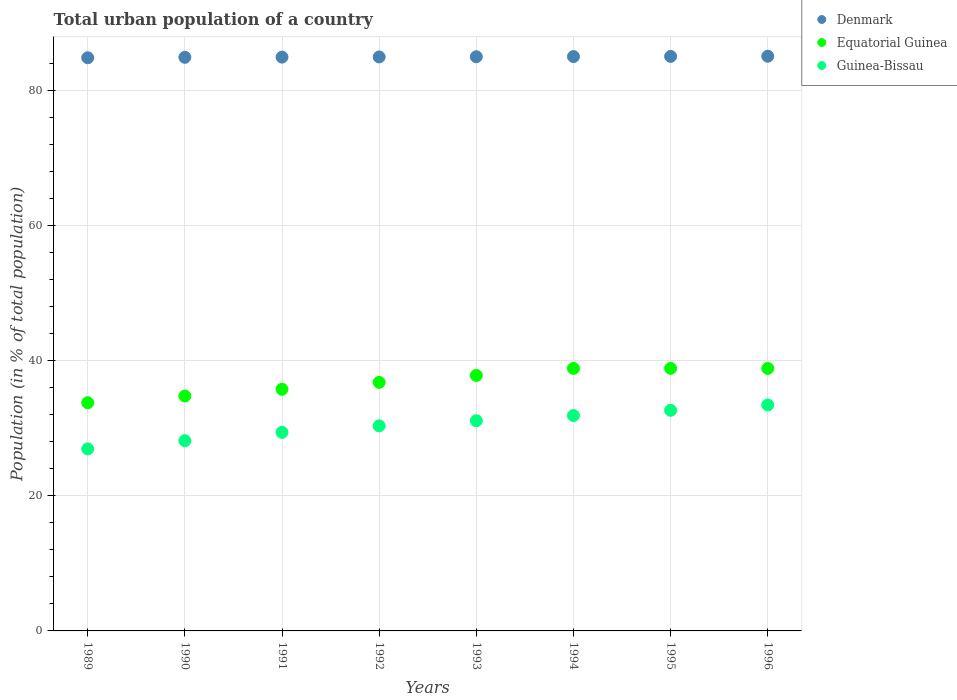What is the urban population in Guinea-Bissau in 1990?
Your answer should be compact. 28.13. Across all years, what is the maximum urban population in Equatorial Guinea?
Provide a succinct answer. 38.83. Across all years, what is the minimum urban population in Equatorial Guinea?
Your answer should be compact. 33.76. What is the total urban population in Equatorial Guinea in the graph?
Make the answer very short. 295.3. What is the difference between the urban population in Guinea-Bissau in 1991 and that in 1994?
Provide a short and direct response. -2.49. What is the difference between the urban population in Guinea-Bissau in 1994 and the urban population in Equatorial Guinea in 1995?
Your answer should be compact. -6.98. What is the average urban population in Guinea-Bissau per year?
Your response must be concise. 30.47. In the year 1993, what is the difference between the urban population in Equatorial Guinea and urban population in Denmark?
Your answer should be compact. -47.13. In how many years, is the urban population in Denmark greater than 56 %?
Provide a short and direct response. 8. What is the ratio of the urban population in Guinea-Bissau in 1992 to that in 1994?
Provide a succinct answer. 0.95. What is the difference between the highest and the second highest urban population in Guinea-Bissau?
Provide a succinct answer. 0.79. What is the difference between the highest and the lowest urban population in Denmark?
Make the answer very short. 0.23. In how many years, is the urban population in Denmark greater than the average urban population in Denmark taken over all years?
Give a very brief answer. 4. Is it the case that in every year, the sum of the urban population in Equatorial Guinea and urban population in Denmark  is greater than the urban population in Guinea-Bissau?
Your response must be concise. Yes. Does the urban population in Guinea-Bissau monotonically increase over the years?
Offer a terse response. Yes. Is the urban population in Guinea-Bissau strictly greater than the urban population in Equatorial Guinea over the years?
Your response must be concise. No. Is the urban population in Denmark strictly less than the urban population in Guinea-Bissau over the years?
Ensure brevity in your answer.  No. How many dotlines are there?
Your response must be concise. 3. How many years are there in the graph?
Provide a succinct answer. 8. What is the difference between two consecutive major ticks on the Y-axis?
Ensure brevity in your answer.  20. Are the values on the major ticks of Y-axis written in scientific E-notation?
Your answer should be compact. No. Where does the legend appear in the graph?
Make the answer very short. Top right. How many legend labels are there?
Give a very brief answer. 3. What is the title of the graph?
Provide a succinct answer. Total urban population of a country. Does "Israel" appear as one of the legend labels in the graph?
Offer a very short reply. No. What is the label or title of the X-axis?
Offer a very short reply. Years. What is the label or title of the Y-axis?
Ensure brevity in your answer.  Population (in % of total population). What is the Population (in % of total population) of Denmark in 1989?
Provide a succinct answer. 84.78. What is the Population (in % of total population) in Equatorial Guinea in 1989?
Ensure brevity in your answer.  33.76. What is the Population (in % of total population) of Guinea-Bissau in 1989?
Offer a terse response. 26.92. What is the Population (in % of total population) of Denmark in 1990?
Offer a terse response. 84.84. What is the Population (in % of total population) in Equatorial Guinea in 1990?
Make the answer very short. 34.74. What is the Population (in % of total population) in Guinea-Bissau in 1990?
Your answer should be very brief. 28.13. What is the Population (in % of total population) in Denmark in 1991?
Offer a very short reply. 84.87. What is the Population (in % of total population) of Equatorial Guinea in 1991?
Your answer should be very brief. 35.75. What is the Population (in % of total population) in Guinea-Bissau in 1991?
Your answer should be very brief. 29.37. What is the Population (in % of total population) in Denmark in 1992?
Make the answer very short. 84.9. What is the Population (in % of total population) in Equatorial Guinea in 1992?
Make the answer very short. 36.77. What is the Population (in % of total population) of Guinea-Bissau in 1992?
Keep it short and to the point. 30.34. What is the Population (in % of total population) in Denmark in 1993?
Provide a succinct answer. 84.92. What is the Population (in % of total population) of Equatorial Guinea in 1993?
Offer a terse response. 37.79. What is the Population (in % of total population) of Guinea-Bissau in 1993?
Ensure brevity in your answer.  31.09. What is the Population (in % of total population) in Denmark in 1994?
Offer a very short reply. 84.95. What is the Population (in % of total population) of Equatorial Guinea in 1994?
Your answer should be compact. 38.83. What is the Population (in % of total population) in Guinea-Bissau in 1994?
Give a very brief answer. 31.86. What is the Population (in % of total population) in Denmark in 1995?
Provide a succinct answer. 84.98. What is the Population (in % of total population) of Equatorial Guinea in 1995?
Ensure brevity in your answer.  38.83. What is the Population (in % of total population) of Guinea-Bissau in 1995?
Offer a very short reply. 32.63. What is the Population (in % of total population) in Denmark in 1996?
Your response must be concise. 85.01. What is the Population (in % of total population) in Equatorial Guinea in 1996?
Your answer should be very brief. 38.83. What is the Population (in % of total population) in Guinea-Bissau in 1996?
Your answer should be compact. 33.42. Across all years, what is the maximum Population (in % of total population) in Denmark?
Provide a short and direct response. 85.01. Across all years, what is the maximum Population (in % of total population) in Equatorial Guinea?
Give a very brief answer. 38.83. Across all years, what is the maximum Population (in % of total population) in Guinea-Bissau?
Provide a short and direct response. 33.42. Across all years, what is the minimum Population (in % of total population) in Denmark?
Make the answer very short. 84.78. Across all years, what is the minimum Population (in % of total population) of Equatorial Guinea?
Offer a very short reply. 33.76. Across all years, what is the minimum Population (in % of total population) of Guinea-Bissau?
Offer a terse response. 26.92. What is the total Population (in % of total population) in Denmark in the graph?
Offer a terse response. 679.25. What is the total Population (in % of total population) of Equatorial Guinea in the graph?
Provide a short and direct response. 295.3. What is the total Population (in % of total population) of Guinea-Bissau in the graph?
Provide a short and direct response. 243.76. What is the difference between the Population (in % of total population) of Denmark in 1989 and that in 1990?
Your answer should be compact. -0.07. What is the difference between the Population (in % of total population) of Equatorial Guinea in 1989 and that in 1990?
Offer a very short reply. -0.99. What is the difference between the Population (in % of total population) in Guinea-Bissau in 1989 and that in 1990?
Keep it short and to the point. -1.21. What is the difference between the Population (in % of total population) of Denmark in 1989 and that in 1991?
Give a very brief answer. -0.09. What is the difference between the Population (in % of total population) of Equatorial Guinea in 1989 and that in 1991?
Provide a short and direct response. -1.99. What is the difference between the Population (in % of total population) in Guinea-Bissau in 1989 and that in 1991?
Keep it short and to the point. -2.45. What is the difference between the Population (in % of total population) in Denmark in 1989 and that in 1992?
Give a very brief answer. -0.12. What is the difference between the Population (in % of total population) of Equatorial Guinea in 1989 and that in 1992?
Provide a succinct answer. -3.01. What is the difference between the Population (in % of total population) of Guinea-Bissau in 1989 and that in 1992?
Your answer should be compact. -3.41. What is the difference between the Population (in % of total population) of Denmark in 1989 and that in 1993?
Make the answer very short. -0.15. What is the difference between the Population (in % of total population) of Equatorial Guinea in 1989 and that in 1993?
Your answer should be compact. -4.04. What is the difference between the Population (in % of total population) of Guinea-Bissau in 1989 and that in 1993?
Provide a succinct answer. -4.17. What is the difference between the Population (in % of total population) in Denmark in 1989 and that in 1994?
Ensure brevity in your answer.  -0.17. What is the difference between the Population (in % of total population) in Equatorial Guinea in 1989 and that in 1994?
Your response must be concise. -5.08. What is the difference between the Population (in % of total population) in Guinea-Bissau in 1989 and that in 1994?
Your answer should be very brief. -4.93. What is the difference between the Population (in % of total population) in Denmark in 1989 and that in 1995?
Give a very brief answer. -0.2. What is the difference between the Population (in % of total population) of Equatorial Guinea in 1989 and that in 1995?
Your answer should be compact. -5.08. What is the difference between the Population (in % of total population) of Guinea-Bissau in 1989 and that in 1995?
Your answer should be very brief. -5.71. What is the difference between the Population (in % of total population) of Denmark in 1989 and that in 1996?
Provide a short and direct response. -0.23. What is the difference between the Population (in % of total population) of Equatorial Guinea in 1989 and that in 1996?
Offer a terse response. -5.07. What is the difference between the Population (in % of total population) in Guinea-Bissau in 1989 and that in 1996?
Your response must be concise. -6.5. What is the difference between the Population (in % of total population) in Denmark in 1990 and that in 1991?
Offer a very short reply. -0.03. What is the difference between the Population (in % of total population) in Equatorial Guinea in 1990 and that in 1991?
Your answer should be very brief. -1. What is the difference between the Population (in % of total population) of Guinea-Bissau in 1990 and that in 1991?
Keep it short and to the point. -1.24. What is the difference between the Population (in % of total population) in Denmark in 1990 and that in 1992?
Offer a very short reply. -0.06. What is the difference between the Population (in % of total population) of Equatorial Guinea in 1990 and that in 1992?
Offer a very short reply. -2.02. What is the difference between the Population (in % of total population) in Guinea-Bissau in 1990 and that in 1992?
Keep it short and to the point. -2.2. What is the difference between the Population (in % of total population) of Denmark in 1990 and that in 1993?
Your answer should be very brief. -0.08. What is the difference between the Population (in % of total population) of Equatorial Guinea in 1990 and that in 1993?
Provide a short and direct response. -3.05. What is the difference between the Population (in % of total population) of Guinea-Bissau in 1990 and that in 1993?
Your answer should be compact. -2.96. What is the difference between the Population (in % of total population) in Denmark in 1990 and that in 1994?
Offer a terse response. -0.11. What is the difference between the Population (in % of total population) in Equatorial Guinea in 1990 and that in 1994?
Ensure brevity in your answer.  -4.09. What is the difference between the Population (in % of total population) of Guinea-Bissau in 1990 and that in 1994?
Offer a terse response. -3.73. What is the difference between the Population (in % of total population) of Denmark in 1990 and that in 1995?
Offer a very short reply. -0.14. What is the difference between the Population (in % of total population) in Equatorial Guinea in 1990 and that in 1995?
Your answer should be very brief. -4.09. What is the difference between the Population (in % of total population) in Guinea-Bissau in 1990 and that in 1995?
Ensure brevity in your answer.  -4.5. What is the difference between the Population (in % of total population) in Denmark in 1990 and that in 1996?
Provide a short and direct response. -0.16. What is the difference between the Population (in % of total population) in Equatorial Guinea in 1990 and that in 1996?
Provide a short and direct response. -4.08. What is the difference between the Population (in % of total population) of Guinea-Bissau in 1990 and that in 1996?
Your answer should be compact. -5.29. What is the difference between the Population (in % of total population) of Denmark in 1991 and that in 1992?
Ensure brevity in your answer.  -0.03. What is the difference between the Population (in % of total population) of Equatorial Guinea in 1991 and that in 1992?
Offer a terse response. -1.02. What is the difference between the Population (in % of total population) in Guinea-Bissau in 1991 and that in 1992?
Your answer should be compact. -0.96. What is the difference between the Population (in % of total population) of Denmark in 1991 and that in 1993?
Offer a terse response. -0.05. What is the difference between the Population (in % of total population) of Equatorial Guinea in 1991 and that in 1993?
Provide a short and direct response. -2.04. What is the difference between the Population (in % of total population) in Guinea-Bissau in 1991 and that in 1993?
Your response must be concise. -1.72. What is the difference between the Population (in % of total population) of Denmark in 1991 and that in 1994?
Your answer should be compact. -0.08. What is the difference between the Population (in % of total population) in Equatorial Guinea in 1991 and that in 1994?
Your answer should be compact. -3.08. What is the difference between the Population (in % of total population) of Guinea-Bissau in 1991 and that in 1994?
Keep it short and to the point. -2.49. What is the difference between the Population (in % of total population) of Denmark in 1991 and that in 1995?
Your response must be concise. -0.11. What is the difference between the Population (in % of total population) of Equatorial Guinea in 1991 and that in 1995?
Keep it short and to the point. -3.09. What is the difference between the Population (in % of total population) of Guinea-Bissau in 1991 and that in 1995?
Offer a very short reply. -3.26. What is the difference between the Population (in % of total population) in Denmark in 1991 and that in 1996?
Make the answer very short. -0.14. What is the difference between the Population (in % of total population) in Equatorial Guinea in 1991 and that in 1996?
Your response must be concise. -3.08. What is the difference between the Population (in % of total population) in Guinea-Bissau in 1991 and that in 1996?
Make the answer very short. -4.05. What is the difference between the Population (in % of total population) in Denmark in 1992 and that in 1993?
Make the answer very short. -0.03. What is the difference between the Population (in % of total population) of Equatorial Guinea in 1992 and that in 1993?
Provide a succinct answer. -1.03. What is the difference between the Population (in % of total population) in Guinea-Bissau in 1992 and that in 1993?
Make the answer very short. -0.76. What is the difference between the Population (in % of total population) of Denmark in 1992 and that in 1994?
Your response must be concise. -0.05. What is the difference between the Population (in % of total population) in Equatorial Guinea in 1992 and that in 1994?
Keep it short and to the point. -2.06. What is the difference between the Population (in % of total population) in Guinea-Bissau in 1992 and that in 1994?
Keep it short and to the point. -1.52. What is the difference between the Population (in % of total population) of Denmark in 1992 and that in 1995?
Offer a terse response. -0.08. What is the difference between the Population (in % of total population) of Equatorial Guinea in 1992 and that in 1995?
Make the answer very short. -2.07. What is the difference between the Population (in % of total population) in Guinea-Bissau in 1992 and that in 1995?
Offer a terse response. -2.3. What is the difference between the Population (in % of total population) in Denmark in 1992 and that in 1996?
Your answer should be compact. -0.11. What is the difference between the Population (in % of total population) of Equatorial Guinea in 1992 and that in 1996?
Your response must be concise. -2.06. What is the difference between the Population (in % of total population) of Guinea-Bissau in 1992 and that in 1996?
Your response must be concise. -3.08. What is the difference between the Population (in % of total population) of Denmark in 1993 and that in 1994?
Your answer should be compact. -0.03. What is the difference between the Population (in % of total population) in Equatorial Guinea in 1993 and that in 1994?
Provide a succinct answer. -1.04. What is the difference between the Population (in % of total population) in Guinea-Bissau in 1993 and that in 1994?
Provide a short and direct response. -0.77. What is the difference between the Population (in % of total population) of Denmark in 1993 and that in 1995?
Keep it short and to the point. -0.05. What is the difference between the Population (in % of total population) of Equatorial Guinea in 1993 and that in 1995?
Give a very brief answer. -1.04. What is the difference between the Population (in % of total population) in Guinea-Bissau in 1993 and that in 1995?
Ensure brevity in your answer.  -1.54. What is the difference between the Population (in % of total population) in Denmark in 1993 and that in 1996?
Keep it short and to the point. -0.08. What is the difference between the Population (in % of total population) of Equatorial Guinea in 1993 and that in 1996?
Your answer should be very brief. -1.04. What is the difference between the Population (in % of total population) of Guinea-Bissau in 1993 and that in 1996?
Ensure brevity in your answer.  -2.33. What is the difference between the Population (in % of total population) of Denmark in 1994 and that in 1995?
Your answer should be very brief. -0.03. What is the difference between the Population (in % of total population) of Equatorial Guinea in 1994 and that in 1995?
Provide a succinct answer. -0. What is the difference between the Population (in % of total population) in Guinea-Bissau in 1994 and that in 1995?
Your answer should be very brief. -0.78. What is the difference between the Population (in % of total population) of Denmark in 1994 and that in 1996?
Your answer should be compact. -0.05. What is the difference between the Population (in % of total population) of Equatorial Guinea in 1994 and that in 1996?
Offer a very short reply. 0. What is the difference between the Population (in % of total population) in Guinea-Bissau in 1994 and that in 1996?
Ensure brevity in your answer.  -1.56. What is the difference between the Population (in % of total population) in Denmark in 1995 and that in 1996?
Provide a succinct answer. -0.03. What is the difference between the Population (in % of total population) in Equatorial Guinea in 1995 and that in 1996?
Provide a succinct answer. 0.01. What is the difference between the Population (in % of total population) of Guinea-Bissau in 1995 and that in 1996?
Keep it short and to the point. -0.79. What is the difference between the Population (in % of total population) of Denmark in 1989 and the Population (in % of total population) of Equatorial Guinea in 1990?
Ensure brevity in your answer.  50.03. What is the difference between the Population (in % of total population) in Denmark in 1989 and the Population (in % of total population) in Guinea-Bissau in 1990?
Your answer should be compact. 56.65. What is the difference between the Population (in % of total population) in Equatorial Guinea in 1989 and the Population (in % of total population) in Guinea-Bissau in 1990?
Offer a very short reply. 5.62. What is the difference between the Population (in % of total population) of Denmark in 1989 and the Population (in % of total population) of Equatorial Guinea in 1991?
Provide a succinct answer. 49.03. What is the difference between the Population (in % of total population) in Denmark in 1989 and the Population (in % of total population) in Guinea-Bissau in 1991?
Provide a succinct answer. 55.41. What is the difference between the Population (in % of total population) of Equatorial Guinea in 1989 and the Population (in % of total population) of Guinea-Bissau in 1991?
Ensure brevity in your answer.  4.38. What is the difference between the Population (in % of total population) of Denmark in 1989 and the Population (in % of total population) of Equatorial Guinea in 1992?
Your answer should be very brief. 48.01. What is the difference between the Population (in % of total population) of Denmark in 1989 and the Population (in % of total population) of Guinea-Bissau in 1992?
Provide a succinct answer. 54.44. What is the difference between the Population (in % of total population) of Equatorial Guinea in 1989 and the Population (in % of total population) of Guinea-Bissau in 1992?
Provide a succinct answer. 3.42. What is the difference between the Population (in % of total population) of Denmark in 1989 and the Population (in % of total population) of Equatorial Guinea in 1993?
Offer a very short reply. 46.98. What is the difference between the Population (in % of total population) of Denmark in 1989 and the Population (in % of total population) of Guinea-Bissau in 1993?
Make the answer very short. 53.69. What is the difference between the Population (in % of total population) of Equatorial Guinea in 1989 and the Population (in % of total population) of Guinea-Bissau in 1993?
Your answer should be compact. 2.66. What is the difference between the Population (in % of total population) in Denmark in 1989 and the Population (in % of total population) in Equatorial Guinea in 1994?
Your response must be concise. 45.95. What is the difference between the Population (in % of total population) in Denmark in 1989 and the Population (in % of total population) in Guinea-Bissau in 1994?
Your answer should be compact. 52.92. What is the difference between the Population (in % of total population) of Equatorial Guinea in 1989 and the Population (in % of total population) of Guinea-Bissau in 1994?
Give a very brief answer. 1.9. What is the difference between the Population (in % of total population) of Denmark in 1989 and the Population (in % of total population) of Equatorial Guinea in 1995?
Provide a short and direct response. 45.94. What is the difference between the Population (in % of total population) in Denmark in 1989 and the Population (in % of total population) in Guinea-Bissau in 1995?
Your response must be concise. 52.14. What is the difference between the Population (in % of total population) of Equatorial Guinea in 1989 and the Population (in % of total population) of Guinea-Bissau in 1995?
Your answer should be compact. 1.12. What is the difference between the Population (in % of total population) of Denmark in 1989 and the Population (in % of total population) of Equatorial Guinea in 1996?
Provide a succinct answer. 45.95. What is the difference between the Population (in % of total population) of Denmark in 1989 and the Population (in % of total population) of Guinea-Bissau in 1996?
Your response must be concise. 51.36. What is the difference between the Population (in % of total population) in Equatorial Guinea in 1989 and the Population (in % of total population) in Guinea-Bissau in 1996?
Your answer should be very brief. 0.34. What is the difference between the Population (in % of total population) in Denmark in 1990 and the Population (in % of total population) in Equatorial Guinea in 1991?
Offer a terse response. 49.09. What is the difference between the Population (in % of total population) of Denmark in 1990 and the Population (in % of total population) of Guinea-Bissau in 1991?
Offer a terse response. 55.47. What is the difference between the Population (in % of total population) of Equatorial Guinea in 1990 and the Population (in % of total population) of Guinea-Bissau in 1991?
Your answer should be very brief. 5.37. What is the difference between the Population (in % of total population) of Denmark in 1990 and the Population (in % of total population) of Equatorial Guinea in 1992?
Your response must be concise. 48.08. What is the difference between the Population (in % of total population) of Denmark in 1990 and the Population (in % of total population) of Guinea-Bissau in 1992?
Your answer should be compact. 54.51. What is the difference between the Population (in % of total population) in Equatorial Guinea in 1990 and the Population (in % of total population) in Guinea-Bissau in 1992?
Your response must be concise. 4.41. What is the difference between the Population (in % of total population) in Denmark in 1990 and the Population (in % of total population) in Equatorial Guinea in 1993?
Offer a terse response. 47.05. What is the difference between the Population (in % of total population) of Denmark in 1990 and the Population (in % of total population) of Guinea-Bissau in 1993?
Provide a succinct answer. 53.75. What is the difference between the Population (in % of total population) of Equatorial Guinea in 1990 and the Population (in % of total population) of Guinea-Bissau in 1993?
Offer a terse response. 3.65. What is the difference between the Population (in % of total population) of Denmark in 1990 and the Population (in % of total population) of Equatorial Guinea in 1994?
Keep it short and to the point. 46.01. What is the difference between the Population (in % of total population) of Denmark in 1990 and the Population (in % of total population) of Guinea-Bissau in 1994?
Provide a short and direct response. 52.99. What is the difference between the Population (in % of total population) of Equatorial Guinea in 1990 and the Population (in % of total population) of Guinea-Bissau in 1994?
Offer a terse response. 2.89. What is the difference between the Population (in % of total population) in Denmark in 1990 and the Population (in % of total population) in Equatorial Guinea in 1995?
Offer a very short reply. 46.01. What is the difference between the Population (in % of total population) in Denmark in 1990 and the Population (in % of total population) in Guinea-Bissau in 1995?
Make the answer very short. 52.21. What is the difference between the Population (in % of total population) in Equatorial Guinea in 1990 and the Population (in % of total population) in Guinea-Bissau in 1995?
Provide a succinct answer. 2.11. What is the difference between the Population (in % of total population) of Denmark in 1990 and the Population (in % of total population) of Equatorial Guinea in 1996?
Keep it short and to the point. 46.01. What is the difference between the Population (in % of total population) in Denmark in 1990 and the Population (in % of total population) in Guinea-Bissau in 1996?
Provide a short and direct response. 51.42. What is the difference between the Population (in % of total population) in Equatorial Guinea in 1990 and the Population (in % of total population) in Guinea-Bissau in 1996?
Your answer should be very brief. 1.32. What is the difference between the Population (in % of total population) in Denmark in 1991 and the Population (in % of total population) in Equatorial Guinea in 1992?
Your response must be concise. 48.1. What is the difference between the Population (in % of total population) in Denmark in 1991 and the Population (in % of total population) in Guinea-Bissau in 1992?
Your answer should be compact. 54.54. What is the difference between the Population (in % of total population) in Equatorial Guinea in 1991 and the Population (in % of total population) in Guinea-Bissau in 1992?
Your response must be concise. 5.41. What is the difference between the Population (in % of total population) in Denmark in 1991 and the Population (in % of total population) in Equatorial Guinea in 1993?
Your answer should be compact. 47.08. What is the difference between the Population (in % of total population) of Denmark in 1991 and the Population (in % of total population) of Guinea-Bissau in 1993?
Provide a short and direct response. 53.78. What is the difference between the Population (in % of total population) in Equatorial Guinea in 1991 and the Population (in % of total population) in Guinea-Bissau in 1993?
Offer a terse response. 4.66. What is the difference between the Population (in % of total population) of Denmark in 1991 and the Population (in % of total population) of Equatorial Guinea in 1994?
Provide a succinct answer. 46.04. What is the difference between the Population (in % of total population) in Denmark in 1991 and the Population (in % of total population) in Guinea-Bissau in 1994?
Provide a short and direct response. 53.01. What is the difference between the Population (in % of total population) of Equatorial Guinea in 1991 and the Population (in % of total population) of Guinea-Bissau in 1994?
Provide a short and direct response. 3.89. What is the difference between the Population (in % of total population) in Denmark in 1991 and the Population (in % of total population) in Equatorial Guinea in 1995?
Keep it short and to the point. 46.04. What is the difference between the Population (in % of total population) in Denmark in 1991 and the Population (in % of total population) in Guinea-Bissau in 1995?
Your answer should be very brief. 52.24. What is the difference between the Population (in % of total population) of Equatorial Guinea in 1991 and the Population (in % of total population) of Guinea-Bissau in 1995?
Keep it short and to the point. 3.12. What is the difference between the Population (in % of total population) of Denmark in 1991 and the Population (in % of total population) of Equatorial Guinea in 1996?
Your response must be concise. 46.04. What is the difference between the Population (in % of total population) in Denmark in 1991 and the Population (in % of total population) in Guinea-Bissau in 1996?
Your answer should be very brief. 51.45. What is the difference between the Population (in % of total population) of Equatorial Guinea in 1991 and the Population (in % of total population) of Guinea-Bissau in 1996?
Provide a succinct answer. 2.33. What is the difference between the Population (in % of total population) of Denmark in 1992 and the Population (in % of total population) of Equatorial Guinea in 1993?
Offer a very short reply. 47.11. What is the difference between the Population (in % of total population) of Denmark in 1992 and the Population (in % of total population) of Guinea-Bissau in 1993?
Provide a succinct answer. 53.81. What is the difference between the Population (in % of total population) in Equatorial Guinea in 1992 and the Population (in % of total population) in Guinea-Bissau in 1993?
Provide a short and direct response. 5.67. What is the difference between the Population (in % of total population) in Denmark in 1992 and the Population (in % of total population) in Equatorial Guinea in 1994?
Provide a succinct answer. 46.07. What is the difference between the Population (in % of total population) of Denmark in 1992 and the Population (in % of total population) of Guinea-Bissau in 1994?
Provide a succinct answer. 53.04. What is the difference between the Population (in % of total population) of Equatorial Guinea in 1992 and the Population (in % of total population) of Guinea-Bissau in 1994?
Offer a terse response. 4.91. What is the difference between the Population (in % of total population) in Denmark in 1992 and the Population (in % of total population) in Equatorial Guinea in 1995?
Offer a terse response. 46.06. What is the difference between the Population (in % of total population) of Denmark in 1992 and the Population (in % of total population) of Guinea-Bissau in 1995?
Provide a short and direct response. 52.27. What is the difference between the Population (in % of total population) of Equatorial Guinea in 1992 and the Population (in % of total population) of Guinea-Bissau in 1995?
Ensure brevity in your answer.  4.13. What is the difference between the Population (in % of total population) in Denmark in 1992 and the Population (in % of total population) in Equatorial Guinea in 1996?
Provide a succinct answer. 46.07. What is the difference between the Population (in % of total population) of Denmark in 1992 and the Population (in % of total population) of Guinea-Bissau in 1996?
Your answer should be compact. 51.48. What is the difference between the Population (in % of total population) of Equatorial Guinea in 1992 and the Population (in % of total population) of Guinea-Bissau in 1996?
Your response must be concise. 3.35. What is the difference between the Population (in % of total population) of Denmark in 1993 and the Population (in % of total population) of Equatorial Guinea in 1994?
Offer a very short reply. 46.09. What is the difference between the Population (in % of total population) of Denmark in 1993 and the Population (in % of total population) of Guinea-Bissau in 1994?
Your answer should be compact. 53.07. What is the difference between the Population (in % of total population) in Equatorial Guinea in 1993 and the Population (in % of total population) in Guinea-Bissau in 1994?
Your response must be concise. 5.93. What is the difference between the Population (in % of total population) in Denmark in 1993 and the Population (in % of total population) in Equatorial Guinea in 1995?
Provide a succinct answer. 46.09. What is the difference between the Population (in % of total population) of Denmark in 1993 and the Population (in % of total population) of Guinea-Bissau in 1995?
Your answer should be very brief. 52.29. What is the difference between the Population (in % of total population) in Equatorial Guinea in 1993 and the Population (in % of total population) in Guinea-Bissau in 1995?
Keep it short and to the point. 5.16. What is the difference between the Population (in % of total population) of Denmark in 1993 and the Population (in % of total population) of Equatorial Guinea in 1996?
Your response must be concise. 46.1. What is the difference between the Population (in % of total population) in Denmark in 1993 and the Population (in % of total population) in Guinea-Bissau in 1996?
Offer a terse response. 51.51. What is the difference between the Population (in % of total population) in Equatorial Guinea in 1993 and the Population (in % of total population) in Guinea-Bissau in 1996?
Give a very brief answer. 4.37. What is the difference between the Population (in % of total population) of Denmark in 1994 and the Population (in % of total population) of Equatorial Guinea in 1995?
Keep it short and to the point. 46.12. What is the difference between the Population (in % of total population) of Denmark in 1994 and the Population (in % of total population) of Guinea-Bissau in 1995?
Offer a very short reply. 52.32. What is the difference between the Population (in % of total population) in Equatorial Guinea in 1994 and the Population (in % of total population) in Guinea-Bissau in 1995?
Provide a succinct answer. 6.2. What is the difference between the Population (in % of total population) in Denmark in 1994 and the Population (in % of total population) in Equatorial Guinea in 1996?
Make the answer very short. 46.12. What is the difference between the Population (in % of total population) of Denmark in 1994 and the Population (in % of total population) of Guinea-Bissau in 1996?
Offer a very short reply. 51.53. What is the difference between the Population (in % of total population) in Equatorial Guinea in 1994 and the Population (in % of total population) in Guinea-Bissau in 1996?
Give a very brief answer. 5.41. What is the difference between the Population (in % of total population) in Denmark in 1995 and the Population (in % of total population) in Equatorial Guinea in 1996?
Provide a succinct answer. 46.15. What is the difference between the Population (in % of total population) in Denmark in 1995 and the Population (in % of total population) in Guinea-Bissau in 1996?
Your answer should be very brief. 51.56. What is the difference between the Population (in % of total population) in Equatorial Guinea in 1995 and the Population (in % of total population) in Guinea-Bissau in 1996?
Your answer should be compact. 5.41. What is the average Population (in % of total population) of Denmark per year?
Your answer should be compact. 84.91. What is the average Population (in % of total population) of Equatorial Guinea per year?
Offer a very short reply. 36.91. What is the average Population (in % of total population) in Guinea-Bissau per year?
Keep it short and to the point. 30.47. In the year 1989, what is the difference between the Population (in % of total population) of Denmark and Population (in % of total population) of Equatorial Guinea?
Offer a very short reply. 51.02. In the year 1989, what is the difference between the Population (in % of total population) in Denmark and Population (in % of total population) in Guinea-Bissau?
Provide a short and direct response. 57.85. In the year 1989, what is the difference between the Population (in % of total population) of Equatorial Guinea and Population (in % of total population) of Guinea-Bissau?
Ensure brevity in your answer.  6.83. In the year 1990, what is the difference between the Population (in % of total population) in Denmark and Population (in % of total population) in Equatorial Guinea?
Offer a terse response. 50.1. In the year 1990, what is the difference between the Population (in % of total population) of Denmark and Population (in % of total population) of Guinea-Bissau?
Ensure brevity in your answer.  56.71. In the year 1990, what is the difference between the Population (in % of total population) in Equatorial Guinea and Population (in % of total population) in Guinea-Bissau?
Offer a very short reply. 6.61. In the year 1991, what is the difference between the Population (in % of total population) of Denmark and Population (in % of total population) of Equatorial Guinea?
Provide a succinct answer. 49.12. In the year 1991, what is the difference between the Population (in % of total population) of Denmark and Population (in % of total population) of Guinea-Bissau?
Your response must be concise. 55.5. In the year 1991, what is the difference between the Population (in % of total population) of Equatorial Guinea and Population (in % of total population) of Guinea-Bissau?
Your answer should be very brief. 6.38. In the year 1992, what is the difference between the Population (in % of total population) of Denmark and Population (in % of total population) of Equatorial Guinea?
Provide a succinct answer. 48.13. In the year 1992, what is the difference between the Population (in % of total population) of Denmark and Population (in % of total population) of Guinea-Bissau?
Offer a very short reply. 54.56. In the year 1992, what is the difference between the Population (in % of total population) of Equatorial Guinea and Population (in % of total population) of Guinea-Bissau?
Offer a very short reply. 6.43. In the year 1993, what is the difference between the Population (in % of total population) in Denmark and Population (in % of total population) in Equatorial Guinea?
Your answer should be compact. 47.13. In the year 1993, what is the difference between the Population (in % of total population) in Denmark and Population (in % of total population) in Guinea-Bissau?
Your answer should be very brief. 53.83. In the year 1993, what is the difference between the Population (in % of total population) in Equatorial Guinea and Population (in % of total population) in Guinea-Bissau?
Make the answer very short. 6.7. In the year 1994, what is the difference between the Population (in % of total population) of Denmark and Population (in % of total population) of Equatorial Guinea?
Your answer should be very brief. 46.12. In the year 1994, what is the difference between the Population (in % of total population) of Denmark and Population (in % of total population) of Guinea-Bissau?
Ensure brevity in your answer.  53.09. In the year 1994, what is the difference between the Population (in % of total population) in Equatorial Guinea and Population (in % of total population) in Guinea-Bissau?
Offer a very short reply. 6.97. In the year 1995, what is the difference between the Population (in % of total population) in Denmark and Population (in % of total population) in Equatorial Guinea?
Offer a very short reply. 46.15. In the year 1995, what is the difference between the Population (in % of total population) in Denmark and Population (in % of total population) in Guinea-Bissau?
Provide a short and direct response. 52.35. In the year 1995, what is the difference between the Population (in % of total population) in Equatorial Guinea and Population (in % of total population) in Guinea-Bissau?
Offer a terse response. 6.2. In the year 1996, what is the difference between the Population (in % of total population) in Denmark and Population (in % of total population) in Equatorial Guinea?
Offer a terse response. 46.18. In the year 1996, what is the difference between the Population (in % of total population) of Denmark and Population (in % of total population) of Guinea-Bissau?
Ensure brevity in your answer.  51.59. In the year 1996, what is the difference between the Population (in % of total population) in Equatorial Guinea and Population (in % of total population) in Guinea-Bissau?
Make the answer very short. 5.41. What is the ratio of the Population (in % of total population) in Denmark in 1989 to that in 1990?
Provide a short and direct response. 1. What is the ratio of the Population (in % of total population) in Equatorial Guinea in 1989 to that in 1990?
Provide a short and direct response. 0.97. What is the ratio of the Population (in % of total population) of Guinea-Bissau in 1989 to that in 1990?
Keep it short and to the point. 0.96. What is the ratio of the Population (in % of total population) in Equatorial Guinea in 1989 to that in 1991?
Offer a very short reply. 0.94. What is the ratio of the Population (in % of total population) in Guinea-Bissau in 1989 to that in 1991?
Make the answer very short. 0.92. What is the ratio of the Population (in % of total population) in Denmark in 1989 to that in 1992?
Ensure brevity in your answer.  1. What is the ratio of the Population (in % of total population) of Equatorial Guinea in 1989 to that in 1992?
Your answer should be compact. 0.92. What is the ratio of the Population (in % of total population) in Guinea-Bissau in 1989 to that in 1992?
Ensure brevity in your answer.  0.89. What is the ratio of the Population (in % of total population) in Equatorial Guinea in 1989 to that in 1993?
Ensure brevity in your answer.  0.89. What is the ratio of the Population (in % of total population) of Guinea-Bissau in 1989 to that in 1993?
Provide a succinct answer. 0.87. What is the ratio of the Population (in % of total population) in Denmark in 1989 to that in 1994?
Make the answer very short. 1. What is the ratio of the Population (in % of total population) of Equatorial Guinea in 1989 to that in 1994?
Offer a very short reply. 0.87. What is the ratio of the Population (in % of total population) of Guinea-Bissau in 1989 to that in 1994?
Your answer should be very brief. 0.85. What is the ratio of the Population (in % of total population) in Equatorial Guinea in 1989 to that in 1995?
Make the answer very short. 0.87. What is the ratio of the Population (in % of total population) in Guinea-Bissau in 1989 to that in 1995?
Offer a terse response. 0.82. What is the ratio of the Population (in % of total population) of Denmark in 1989 to that in 1996?
Your response must be concise. 1. What is the ratio of the Population (in % of total population) in Equatorial Guinea in 1989 to that in 1996?
Keep it short and to the point. 0.87. What is the ratio of the Population (in % of total population) of Guinea-Bissau in 1989 to that in 1996?
Your response must be concise. 0.81. What is the ratio of the Population (in % of total population) in Denmark in 1990 to that in 1991?
Give a very brief answer. 1. What is the ratio of the Population (in % of total population) in Equatorial Guinea in 1990 to that in 1991?
Your response must be concise. 0.97. What is the ratio of the Population (in % of total population) of Guinea-Bissau in 1990 to that in 1991?
Your response must be concise. 0.96. What is the ratio of the Population (in % of total population) in Denmark in 1990 to that in 1992?
Your response must be concise. 1. What is the ratio of the Population (in % of total population) of Equatorial Guinea in 1990 to that in 1992?
Your answer should be very brief. 0.94. What is the ratio of the Population (in % of total population) in Guinea-Bissau in 1990 to that in 1992?
Ensure brevity in your answer.  0.93. What is the ratio of the Population (in % of total population) of Denmark in 1990 to that in 1993?
Provide a short and direct response. 1. What is the ratio of the Population (in % of total population) in Equatorial Guinea in 1990 to that in 1993?
Your answer should be compact. 0.92. What is the ratio of the Population (in % of total population) of Guinea-Bissau in 1990 to that in 1993?
Your answer should be compact. 0.9. What is the ratio of the Population (in % of total population) in Equatorial Guinea in 1990 to that in 1994?
Your answer should be very brief. 0.89. What is the ratio of the Population (in % of total population) in Guinea-Bissau in 1990 to that in 1994?
Your response must be concise. 0.88. What is the ratio of the Population (in % of total population) of Equatorial Guinea in 1990 to that in 1995?
Offer a very short reply. 0.89. What is the ratio of the Population (in % of total population) of Guinea-Bissau in 1990 to that in 1995?
Your answer should be compact. 0.86. What is the ratio of the Population (in % of total population) of Denmark in 1990 to that in 1996?
Make the answer very short. 1. What is the ratio of the Population (in % of total population) in Equatorial Guinea in 1990 to that in 1996?
Keep it short and to the point. 0.89. What is the ratio of the Population (in % of total population) of Guinea-Bissau in 1990 to that in 1996?
Your answer should be very brief. 0.84. What is the ratio of the Population (in % of total population) of Equatorial Guinea in 1991 to that in 1992?
Offer a terse response. 0.97. What is the ratio of the Population (in % of total population) in Guinea-Bissau in 1991 to that in 1992?
Your answer should be compact. 0.97. What is the ratio of the Population (in % of total population) in Equatorial Guinea in 1991 to that in 1993?
Keep it short and to the point. 0.95. What is the ratio of the Population (in % of total population) in Guinea-Bissau in 1991 to that in 1993?
Provide a succinct answer. 0.94. What is the ratio of the Population (in % of total population) in Equatorial Guinea in 1991 to that in 1994?
Make the answer very short. 0.92. What is the ratio of the Population (in % of total population) of Guinea-Bissau in 1991 to that in 1994?
Your answer should be compact. 0.92. What is the ratio of the Population (in % of total population) in Equatorial Guinea in 1991 to that in 1995?
Your answer should be very brief. 0.92. What is the ratio of the Population (in % of total population) in Guinea-Bissau in 1991 to that in 1995?
Make the answer very short. 0.9. What is the ratio of the Population (in % of total population) in Denmark in 1991 to that in 1996?
Offer a very short reply. 1. What is the ratio of the Population (in % of total population) of Equatorial Guinea in 1991 to that in 1996?
Offer a terse response. 0.92. What is the ratio of the Population (in % of total population) of Guinea-Bissau in 1991 to that in 1996?
Offer a very short reply. 0.88. What is the ratio of the Population (in % of total population) of Equatorial Guinea in 1992 to that in 1993?
Provide a short and direct response. 0.97. What is the ratio of the Population (in % of total population) in Guinea-Bissau in 1992 to that in 1993?
Provide a succinct answer. 0.98. What is the ratio of the Population (in % of total population) of Equatorial Guinea in 1992 to that in 1994?
Ensure brevity in your answer.  0.95. What is the ratio of the Population (in % of total population) in Guinea-Bissau in 1992 to that in 1994?
Your response must be concise. 0.95. What is the ratio of the Population (in % of total population) in Equatorial Guinea in 1992 to that in 1995?
Provide a succinct answer. 0.95. What is the ratio of the Population (in % of total population) of Guinea-Bissau in 1992 to that in 1995?
Provide a succinct answer. 0.93. What is the ratio of the Population (in % of total population) of Denmark in 1992 to that in 1996?
Give a very brief answer. 1. What is the ratio of the Population (in % of total population) of Equatorial Guinea in 1992 to that in 1996?
Your answer should be compact. 0.95. What is the ratio of the Population (in % of total population) of Guinea-Bissau in 1992 to that in 1996?
Offer a very short reply. 0.91. What is the ratio of the Population (in % of total population) of Equatorial Guinea in 1993 to that in 1994?
Give a very brief answer. 0.97. What is the ratio of the Population (in % of total population) in Equatorial Guinea in 1993 to that in 1995?
Your answer should be compact. 0.97. What is the ratio of the Population (in % of total population) in Guinea-Bissau in 1993 to that in 1995?
Your answer should be very brief. 0.95. What is the ratio of the Population (in % of total population) of Equatorial Guinea in 1993 to that in 1996?
Your response must be concise. 0.97. What is the ratio of the Population (in % of total population) of Guinea-Bissau in 1993 to that in 1996?
Provide a short and direct response. 0.93. What is the ratio of the Population (in % of total population) of Denmark in 1994 to that in 1995?
Your answer should be very brief. 1. What is the ratio of the Population (in % of total population) of Guinea-Bissau in 1994 to that in 1995?
Make the answer very short. 0.98. What is the ratio of the Population (in % of total population) in Denmark in 1994 to that in 1996?
Your response must be concise. 1. What is the ratio of the Population (in % of total population) of Guinea-Bissau in 1994 to that in 1996?
Offer a terse response. 0.95. What is the ratio of the Population (in % of total population) in Equatorial Guinea in 1995 to that in 1996?
Your answer should be compact. 1. What is the ratio of the Population (in % of total population) of Guinea-Bissau in 1995 to that in 1996?
Your response must be concise. 0.98. What is the difference between the highest and the second highest Population (in % of total population) in Denmark?
Your answer should be compact. 0.03. What is the difference between the highest and the second highest Population (in % of total population) in Equatorial Guinea?
Your response must be concise. 0. What is the difference between the highest and the second highest Population (in % of total population) in Guinea-Bissau?
Offer a very short reply. 0.79. What is the difference between the highest and the lowest Population (in % of total population) of Denmark?
Your answer should be very brief. 0.23. What is the difference between the highest and the lowest Population (in % of total population) of Equatorial Guinea?
Provide a short and direct response. 5.08. What is the difference between the highest and the lowest Population (in % of total population) in Guinea-Bissau?
Ensure brevity in your answer.  6.5. 